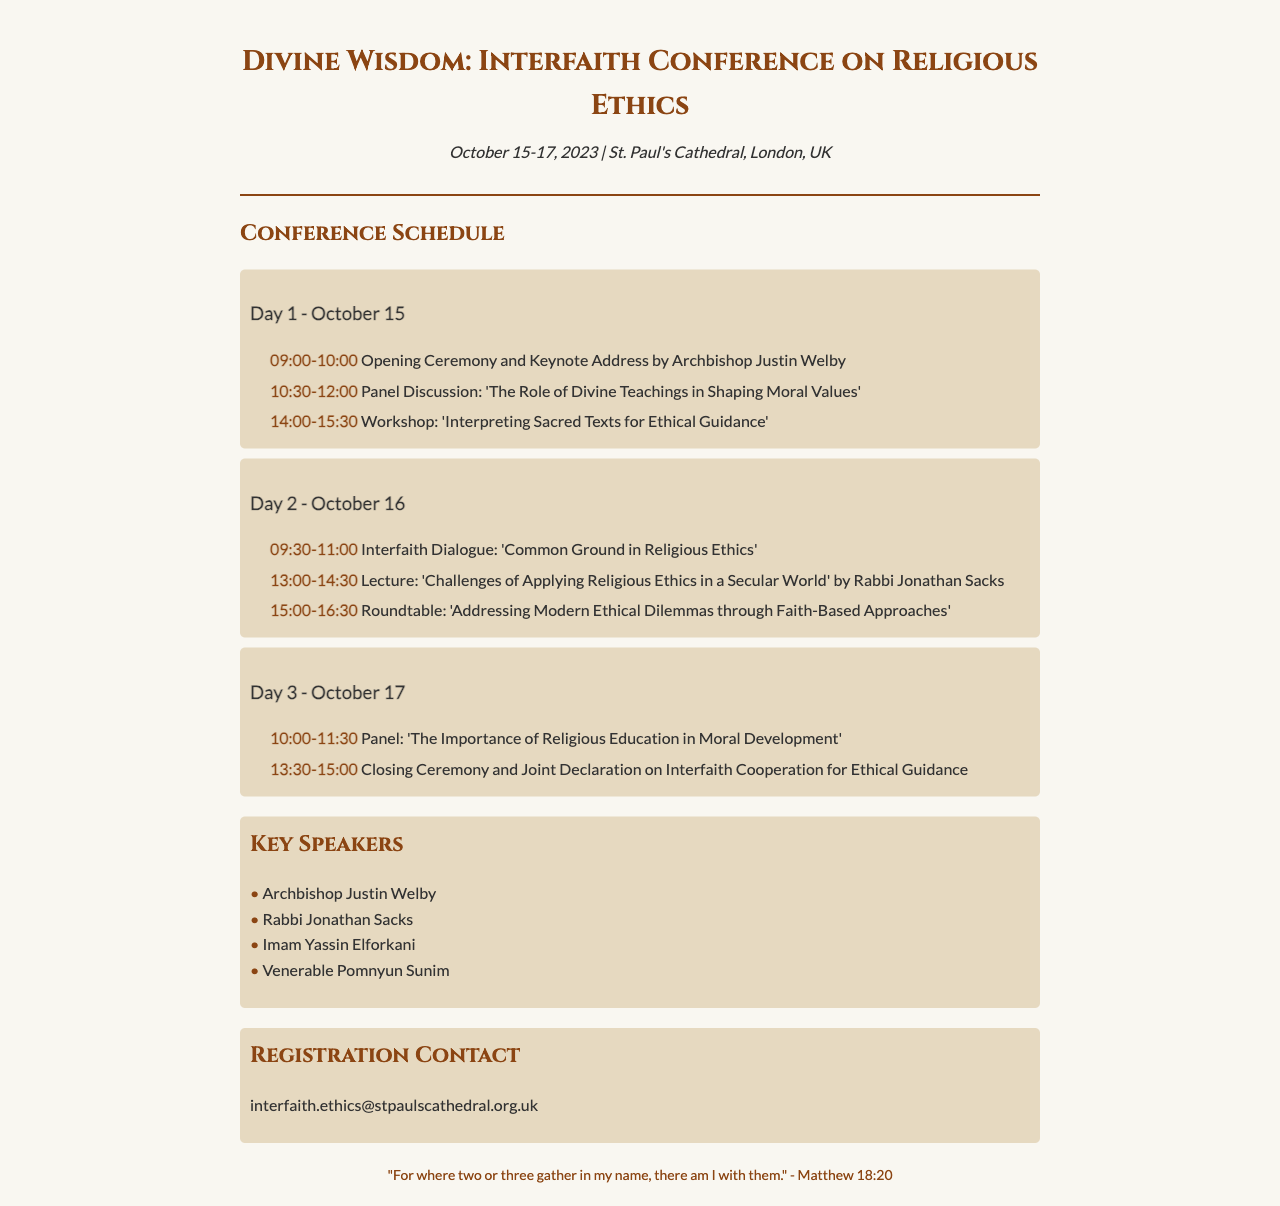What are the dates of the conference? The dates of the conference are clearly stated in the document as October 15-17, 2023.
Answer: October 15-17, 2023 Who is the keynote speaker? The document specifies that the keynote address is by Archbishop Justin Welby.
Answer: Archbishop Justin Welby What is the topic of the second workshop? The schedule indicates that the second workshop focuses on interpreting sacred texts for ethical guidance.
Answer: Interpreting Sacred Texts for Ethical Guidance How many days does the conference span? The document outlines the schedule over a period of three days, indicating the duration of the conference.
Answer: Three days Which panel discussion occurs on Day 3? The document lists the panel discussion as about the importance of religious education in moral development for the final day.
Answer: The Importance of Religious Education in Moral Development What email address is provided for registration contact? The document states the registration contact email is provided directly.
Answer: interfaith.ethics@stpaulscathedral.org.uk What is the title of the lecture on Day 2? The schedule mentions that the lecture on Day 2 is focused on the challenges of applying religious ethics in a secular world.
Answer: Challenges of Applying Religious Ethics in a Secular World Who is a speaker at the conference? The document lists several key speakers, one of which is Rabbi Jonathan Sacks.
Answer: Rabbi Jonathan Sacks What is the time of the closing ceremony? According to the schedule, the closing ceremony takes place at 13:30-15:00 on Day 3.
Answer: 13:30-15:00 